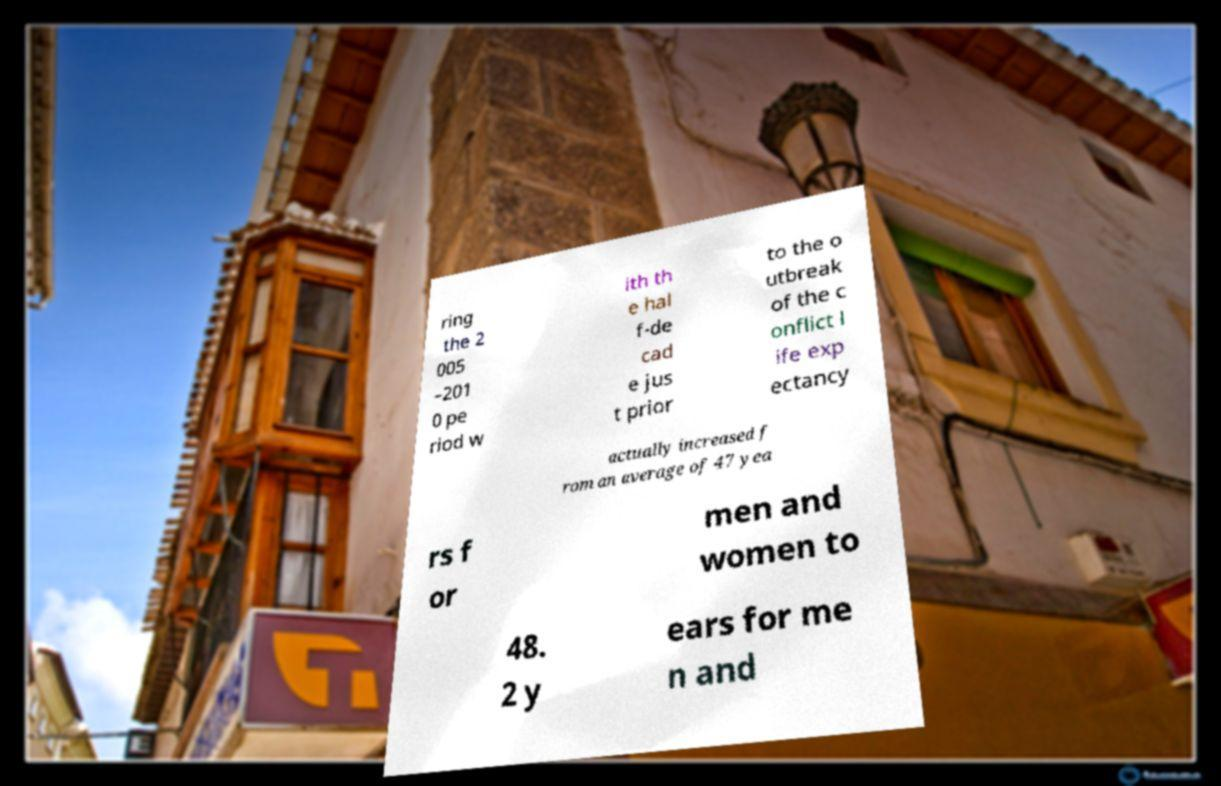Could you assist in decoding the text presented in this image and type it out clearly? ring the 2 005 –201 0 pe riod w ith th e hal f-de cad e jus t prior to the o utbreak of the c onflict l ife exp ectancy actually increased f rom an average of 47 yea rs f or men and women to 48. 2 y ears for me n and 